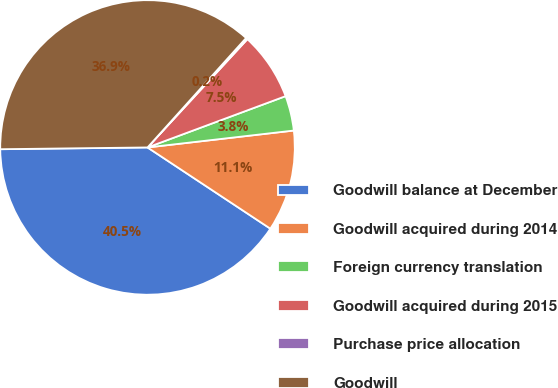Convert chart. <chart><loc_0><loc_0><loc_500><loc_500><pie_chart><fcel>Goodwill balance at December<fcel>Goodwill acquired during 2014<fcel>Foreign currency translation<fcel>Goodwill acquired during 2015<fcel>Purchase price allocation<fcel>Goodwill<nl><fcel>40.51%<fcel>11.13%<fcel>3.83%<fcel>7.48%<fcel>0.19%<fcel>36.86%<nl></chart> 